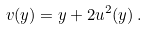Convert formula to latex. <formula><loc_0><loc_0><loc_500><loc_500>v ( y ) = y + 2 u ^ { 2 } ( y ) \, .</formula> 